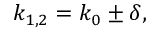<formula> <loc_0><loc_0><loc_500><loc_500>k _ { 1 , 2 } = k _ { 0 } \pm \delta ,</formula> 